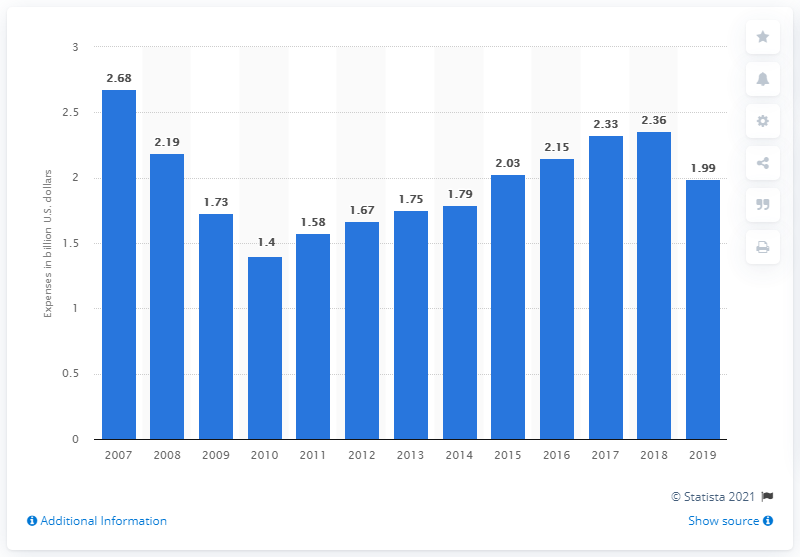Mention a couple of crucial points in this snapshot. In 2019, music publishers spent approximately 1.99 billion US dollars. 